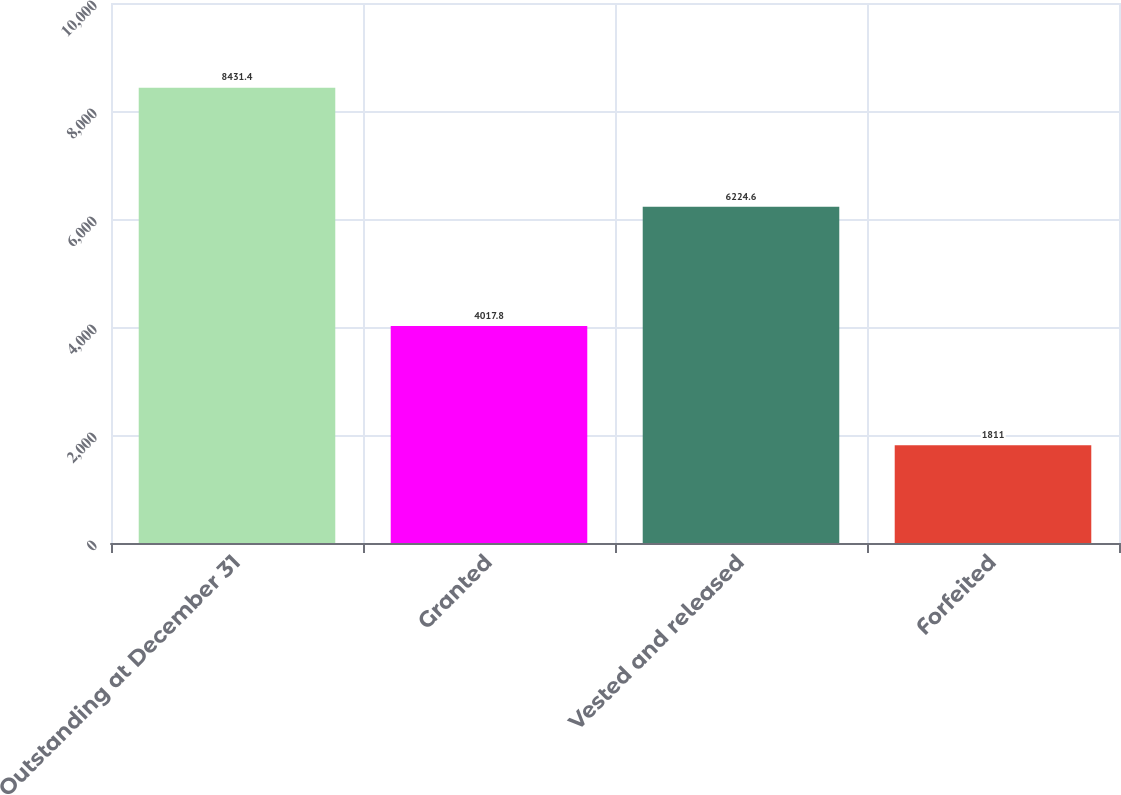<chart> <loc_0><loc_0><loc_500><loc_500><bar_chart><fcel>Outstanding at December 31<fcel>Granted<fcel>Vested and released<fcel>Forfeited<nl><fcel>8431.4<fcel>4017.8<fcel>6224.6<fcel>1811<nl></chart> 